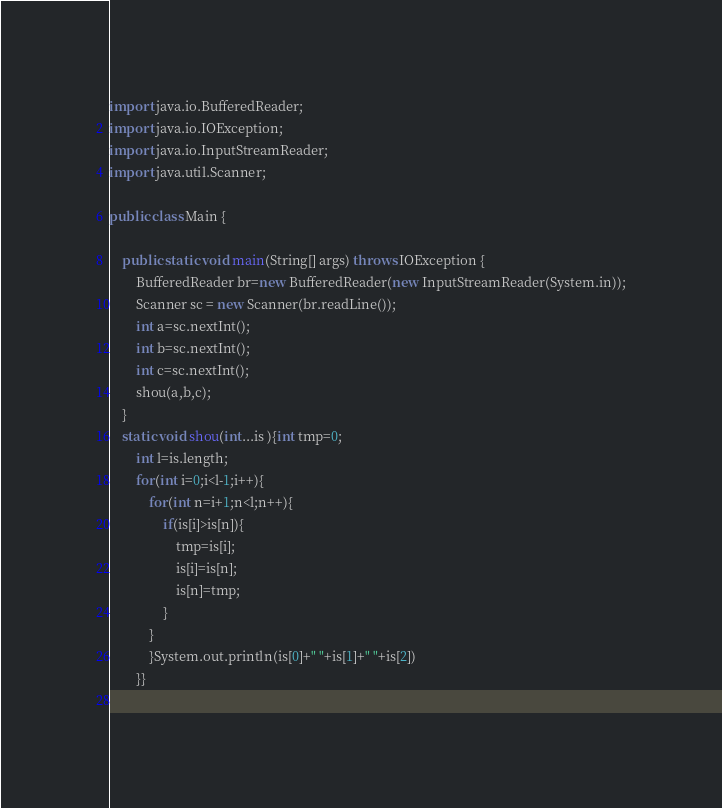<code> <loc_0><loc_0><loc_500><loc_500><_Java_>
import java.io.BufferedReader;
import java.io.IOException;
import java.io.InputStreamReader;
import java.util.Scanner;

public class Main {

	public static void main(String[] args) throws IOException {
		BufferedReader br=new BufferedReader(new InputStreamReader(System.in));
		Scanner sc = new Scanner(br.readLine());
		int a=sc.nextInt();
		int b=sc.nextInt();
		int c=sc.nextInt();
		shou(a,b,c);
	}
	static void shou(int...is ){int tmp=0;
		int l=is.length;
		for(int i=0;i<l-1;i++){
			for(int n=i+1;n<l;n++){
				if(is[i]>is[n]){
					tmp=is[i];
					is[i]=is[n];
					is[n]=tmp;
				}
			}
			}System.out.println(is[0]+" "+is[1]+" "+is[2])
		}}
	</code> 